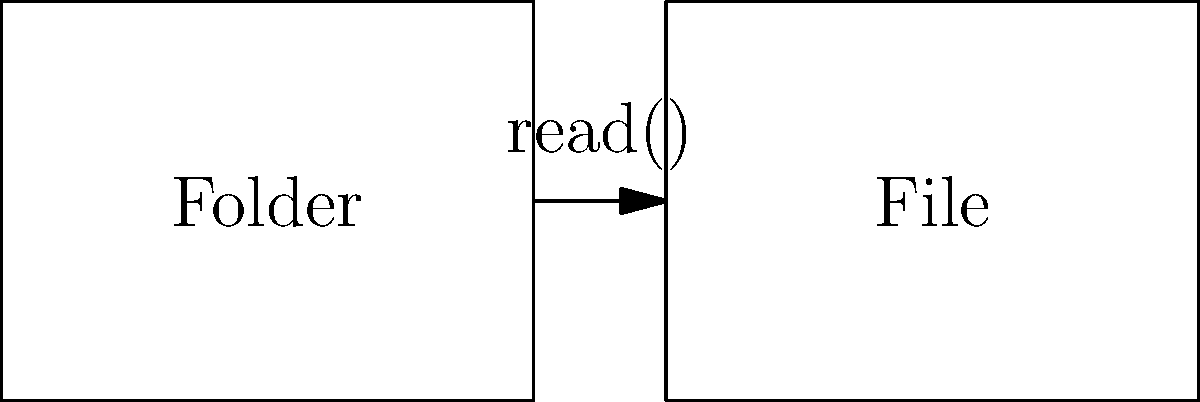In Ruby, which method is commonly used to read the entire contents of a file into a string variable? To read the entire contents of a file in Ruby, we follow these steps:

1. Open the file using the `File.open()` method, specifying the file path and read mode ('r').
2. Use the `read()` method on the opened file object to read all contents into a string.
3. Close the file to free up system resources.

Here's an example of how this is typically done:

```ruby
file_contents = File.open('example.txt', 'r') do |file|
  file.read
end
```

In this code:
- `File.open()` opens the file 'example.txt' in read mode.
- The `do |file|` block receives the opened file object.
- `file.read` reads the entire contents of the file into a string.
- The file is automatically closed when the block ends.
- The result is stored in the `file_contents` variable.

The `read()` method is the key operation that reads the entire file content at once.
Answer: read() 